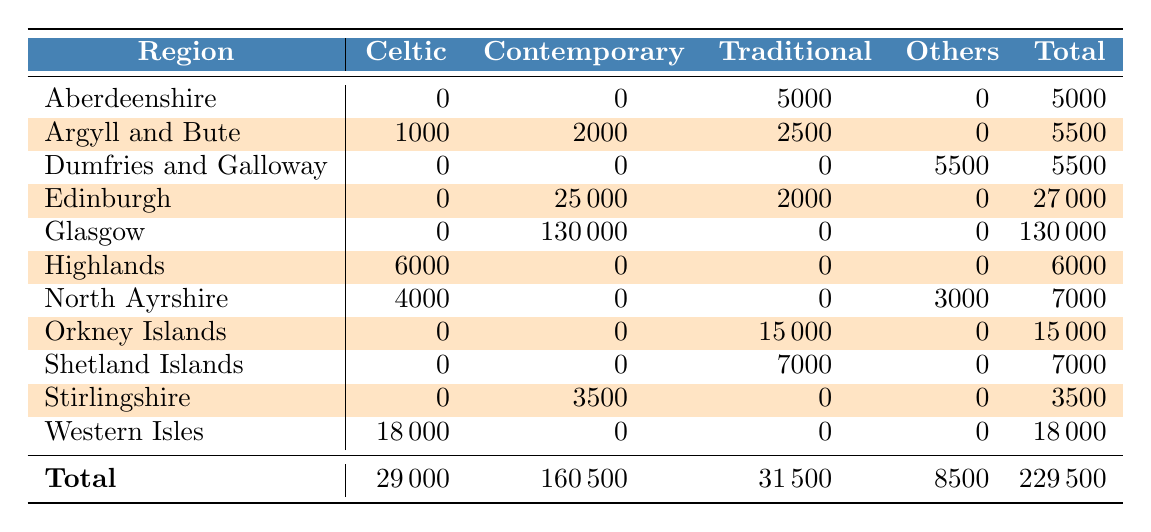What is the total attendance for festivals in Argyll and Bute? The total attendance for Argyll and Bute is the sum of the values in the row for that region: 1000 (Celtic) + 2000 (Contemporary) + 2500 (Traditional) = 5500
Answer: 5500 How many people attended traditional folk festivals in Edinburgh? Referring to the table, the attendance for traditional folk festivals in Edinburgh is 2000, which is clearly stated in the 'Traditional' column under Edinburgh.
Answer: 2000 Which region had the highest total attendance and what was that figure? The total attendance is given in the table in the last column. Glasgow has the highest total attendance at 130000, as evidenced by its total being the greatest among all regions.
Answer: 130000 Was there any attendance recorded for Celtic music in Stirlingshire? Stirlingshire has a value of 0 in the Celtic column. Therefore, there was no attendance recorded for Celtic music in that region.
Answer: No What is the difference in total attendance between Contemporary and Traditional folk music across all regions? The total attendance for Contemporary folk music is 160500, while for Traditional folk music, it is 31500. The difference is calculated as 160500 - 31500 = 129000.
Answer: 129000 How many total festivals were held in total in North Ayrshire, and what were their genres? In North Ayrshire, the table shows two festivals: one Celtic (4000 attendees) and one Country (3000 attendees), making a total of 7000 attendees. Thus, there were two festivals of different genres.
Answer: 2 festivals (Celtic, Country) What proportion of total festival attendance was for World Music? The attendance for World Music is 5500 in Dumfries and Galloway. The total festival attendance is 229500. Therefore, the proportion is calculated as 5500 / 229500, which simplifies to approximately 0.024 or 2.4%.
Answer: 2.4% How many regions had no attendance for Contemporary folk music? Examining the table, the regions that show 0 attendance for Contemporary folk music are Aberdeenshire, Orkney Islands, Shetland Islands, and Western Isles. So there are four regions with no attendance for this genre.
Answer: 4 regions What was the total attendance across all genres for the Highlands? The total attendance for Highlands, taking values from the row for that region, is 6000 in the Celtic column and 0 in all other columns, resulting in a total of 6000.
Answer: 6000 